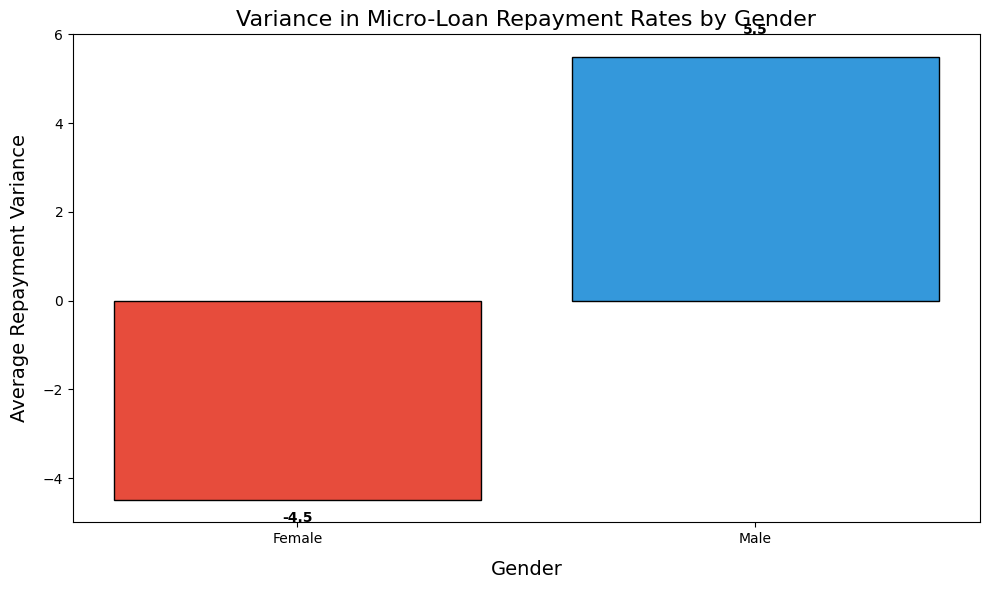Which gender has a higher average repayment variance? By looking at the height of the bars, we see that the bar representing males is taller than the bar representing females, indicating a higher average repayment variance for males compared to females.
Answer: Males What is the mean repayment variance for males? The figure shows the bar for the male group with a label of 5.6, representing their mean repayment variance.
Answer: 5.6 What is the mean repayment variance for females? The figure shows the bar for the female group with a label of -4.6, representing their mean repayment variance.
Answer: -4.6 By how much does the average repayment variance of males exceed that of females? The mean repayment variance for males is 5.6, and for females, it is -4.6. The difference is calculated as 5.6 - (-4.6) = 5.6 + 4.6 = 10.2.
Answer: 10.2 Which gender's average repayment variance falls below zero, and what does this signify? The mean repayment variance for females is below zero (-4.6), while males are above zero (5.6). This indicates that the average repayment variance for females is negative, implying more variability or inconsistency in repayment rates.
Answer: Females What color represents the repayment variance for females? The figure uses different colors to differentiate between positive and negative values. The bar for females is colored red, indicating a negative repayment variance.
Answer: Red How does the height of the bar for males compare to that for females? The male group's bar is taller than that of the female group, indicating a higher average repayment variance for males.
Answer: Taller What logical insight can be drawn about gender disparities in loan repayment based on the bar chart? The chart indicates that males have a higher and positive average repayment variance, while females have a lower and negative average repayment variance, suggesting that males may have more consistent repayment behaviors compared to females.
Answer: Males more consistent If the data were represented in terms of consistency, which group would be considered more consistent or stable based on their repayment variance? Negative variances generally indicate less consistency, while positive variances indicate more stability. Therefore, the male group, having a positive variance (5.6), appears more consistent than the female group, which has a negative variance (-4.6).
Answer: Males 